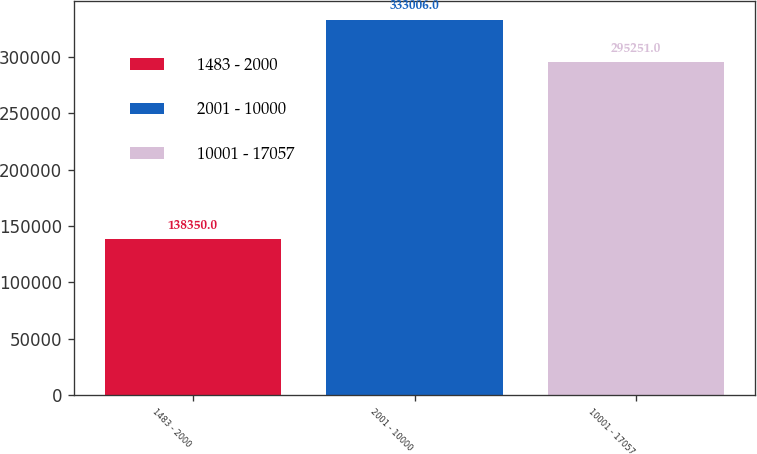<chart> <loc_0><loc_0><loc_500><loc_500><bar_chart><fcel>1483 - 2000<fcel>2001 - 10000<fcel>10001 - 17057<nl><fcel>138350<fcel>333006<fcel>295251<nl></chart> 